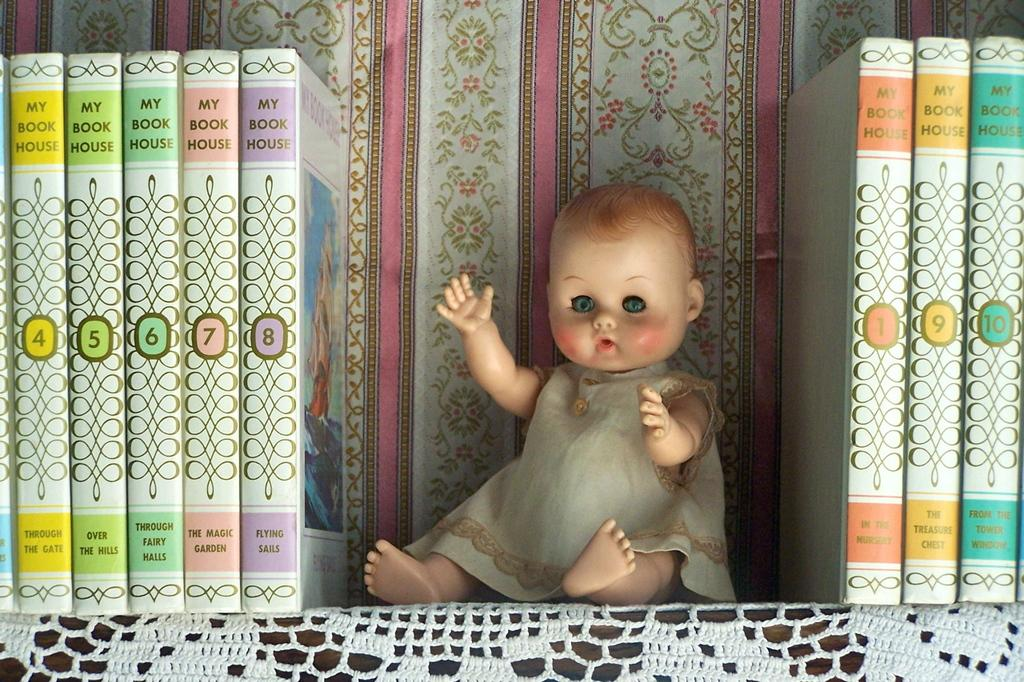<image>
Describe the image concisely. the word house is on the side of the book 